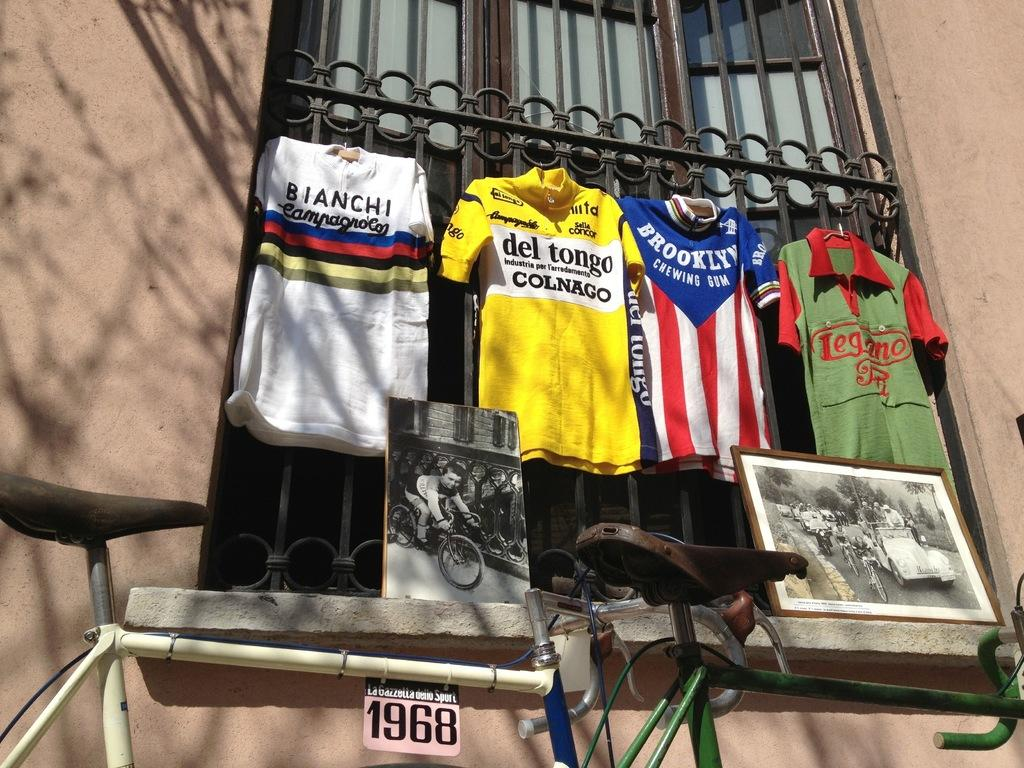<image>
Give a short and clear explanation of the subsequent image. A striped shirt with the word Brooklyn on it is hanging in a window. 